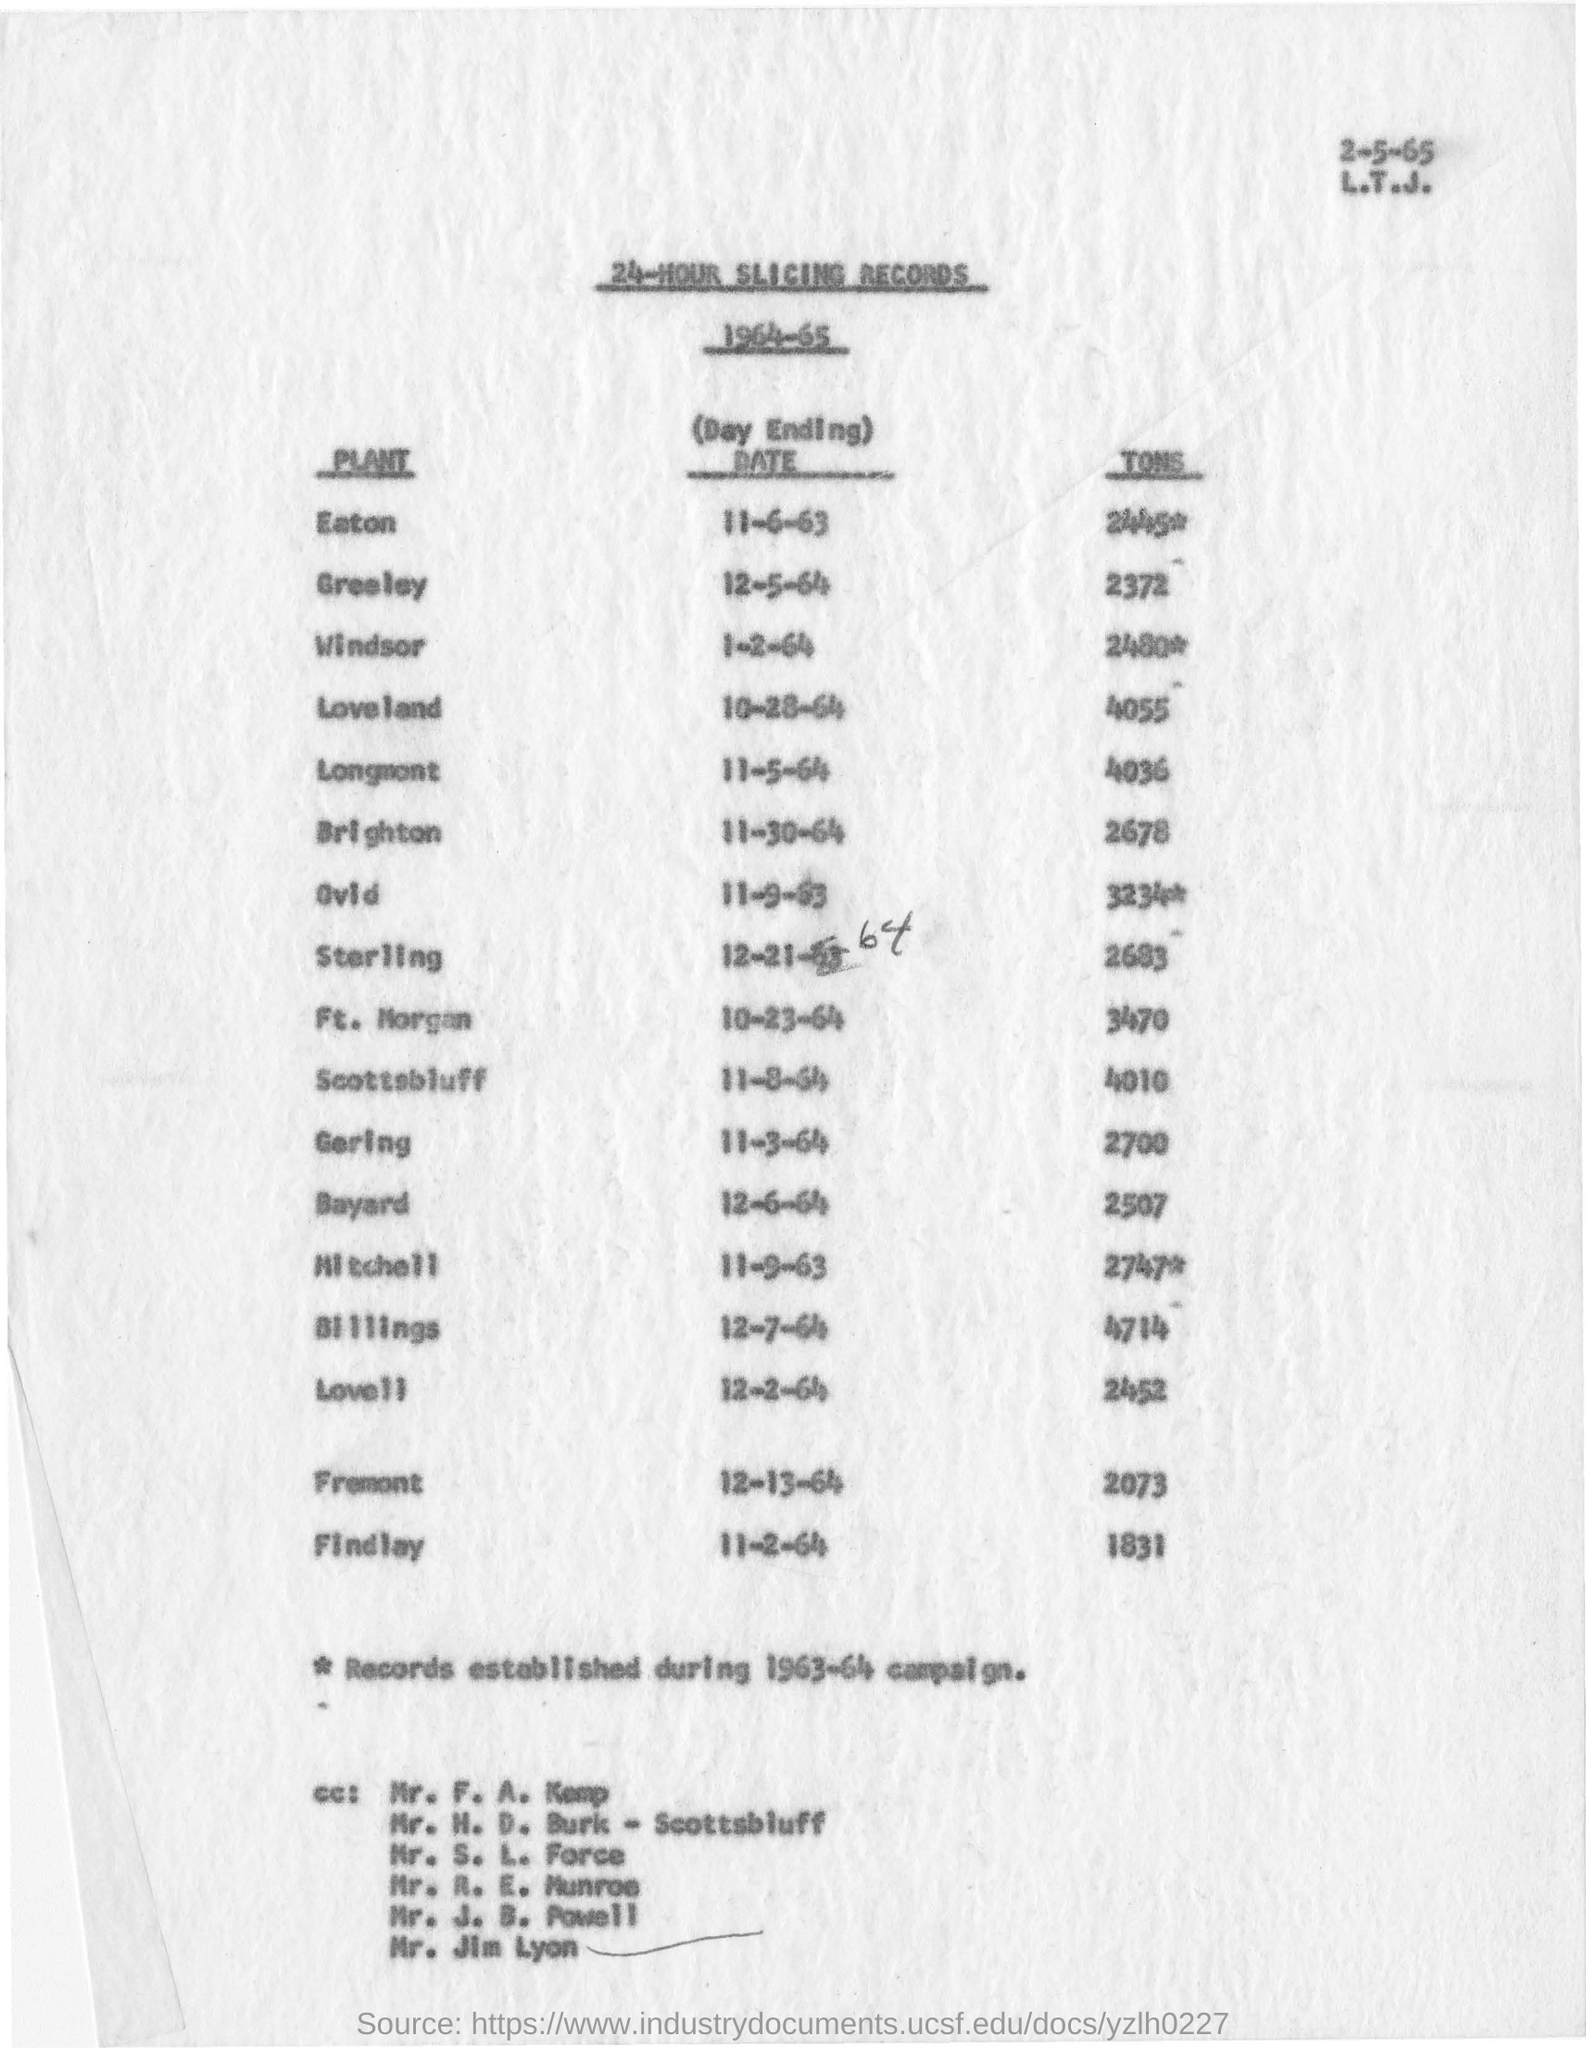Highlight a few significant elements in this photo. On December 7, 1964, a record of 4,714 tons was made. The document is about 24-HOUR SLICING RECORDS. According to recorded data from the Ovid plant, a total of 3234 tons have been reported. These records were collected in the year 1964-65. 